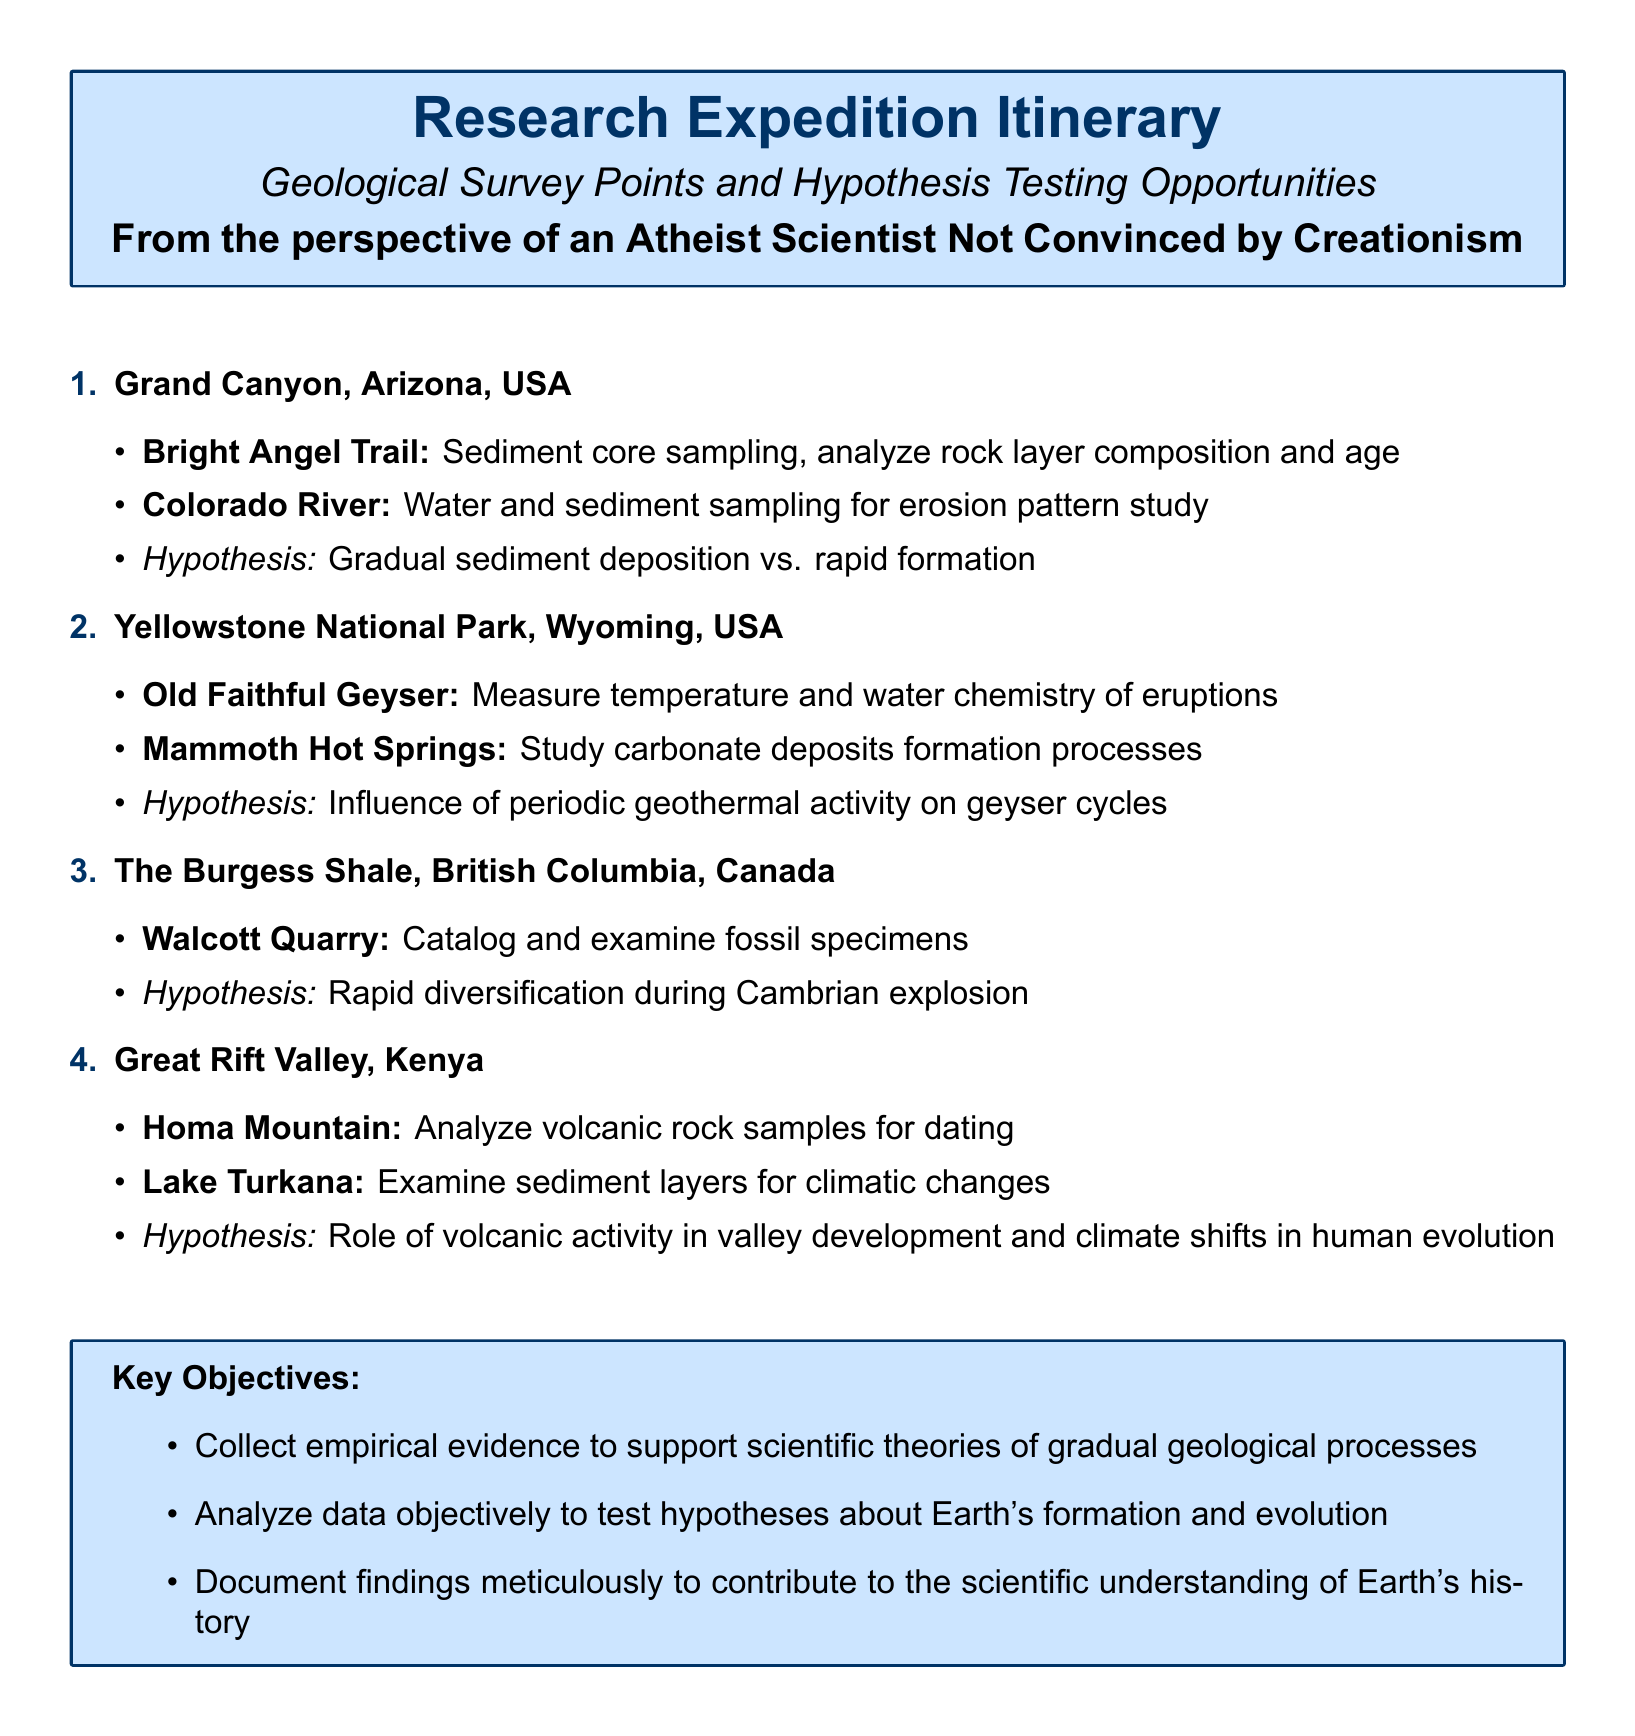What is the first location listed in the itinerary? The first location is specifically named in the document's section about geological survey points.
Answer: Grand Canyon, Arizona, USA What type of sampling is mentioned for the Colorado River? The document describes the specific type of analysis planned for this location under its geological survey points.
Answer: Water and sediment sampling What is one of the key objectives of the research expedition? The document provides a list of objectives that guide the expedition's purpose and activities.
Answer: Collect empirical evidence How many hypotheses are proposed in the itinerary? The number of hypotheses can be counted from the distinct hypotheses stated next to each location in the document.
Answer: Four What geological feature is studied in Yellowstone National Park? This refers to a specific element that the expedition is analyzing at this particular site.
Answer: Old Faithful Geyser What is the hypothesis related to the Great Rift Valley? The hypothesis outlines a specific scientific question concerning geological processes and human evolution at this site.
Answer: Role of volcanic activity in valley development and climate shifts in human evolution What type of deposits are studied at Mammoth Hot Springs? The document provides details on the types of geological formations that are under examination in this location.
Answer: Carbonate deposits Which quarry is associated with the Burgess Shale? The name of the quarry focusing on fossil examination is explicitly given in the document.
Answer: Walcott Quarry 